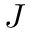Convert formula to latex. <formula><loc_0><loc_0><loc_500><loc_500>J</formula> 